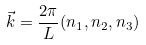Convert formula to latex. <formula><loc_0><loc_0><loc_500><loc_500>\vec { k } = \frac { 2 \pi } { L } ( n _ { 1 } , n _ { 2 } , n _ { 3 } )</formula> 